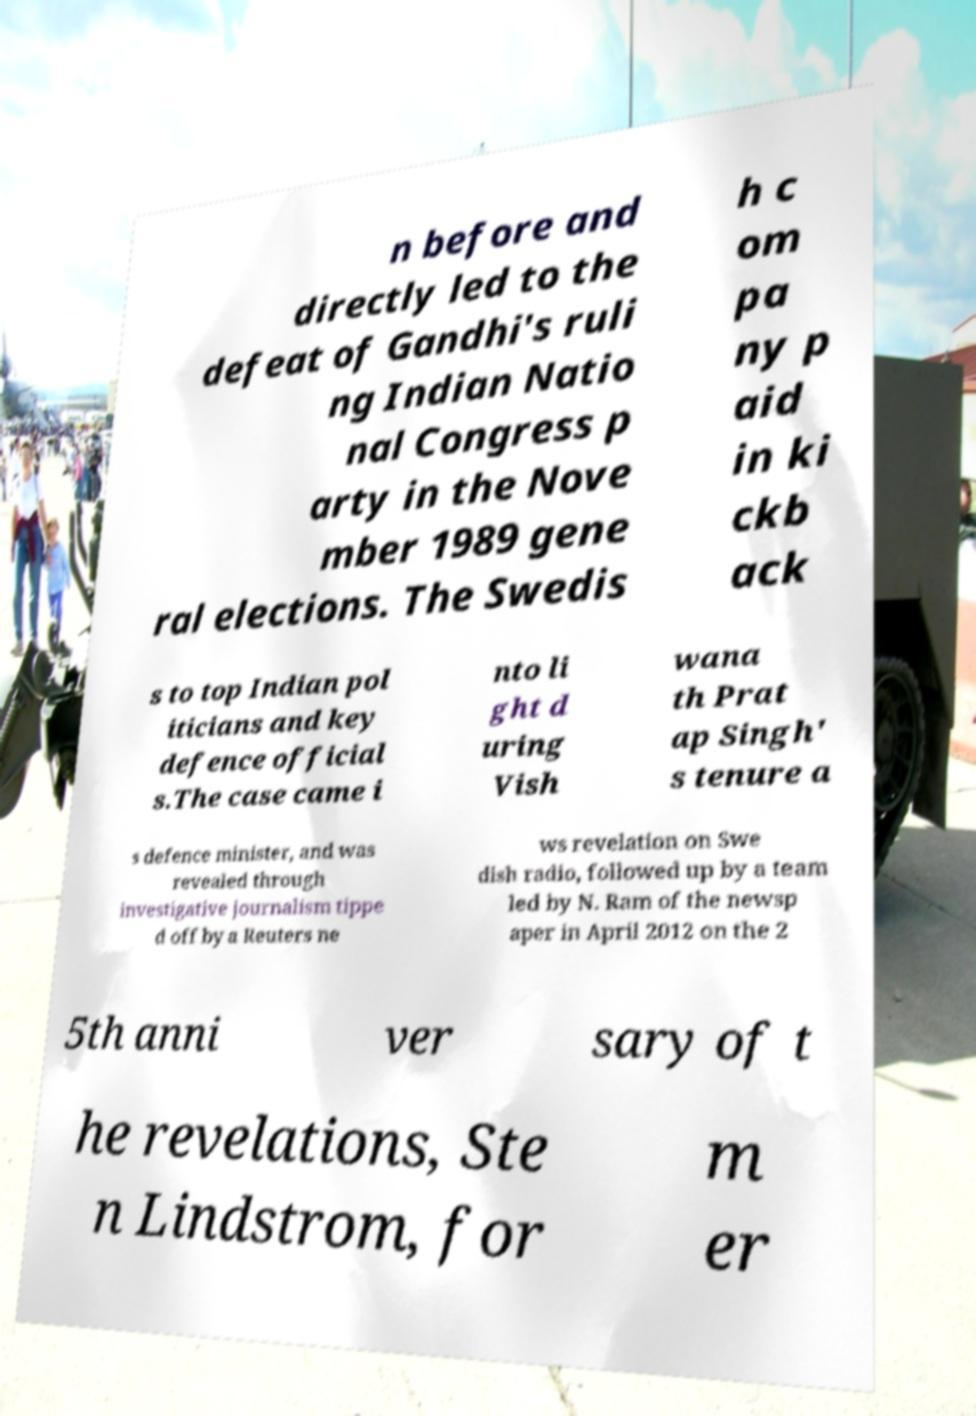Please identify and transcribe the text found in this image. n before and directly led to the defeat of Gandhi's ruli ng Indian Natio nal Congress p arty in the Nove mber 1989 gene ral elections. The Swedis h c om pa ny p aid in ki ckb ack s to top Indian pol iticians and key defence official s.The case came i nto li ght d uring Vish wana th Prat ap Singh' s tenure a s defence minister, and was revealed through investigative journalism tippe d off by a Reuters ne ws revelation on Swe dish radio, followed up by a team led by N. Ram of the newsp aper in April 2012 on the 2 5th anni ver sary of t he revelations, Ste n Lindstrom, for m er 